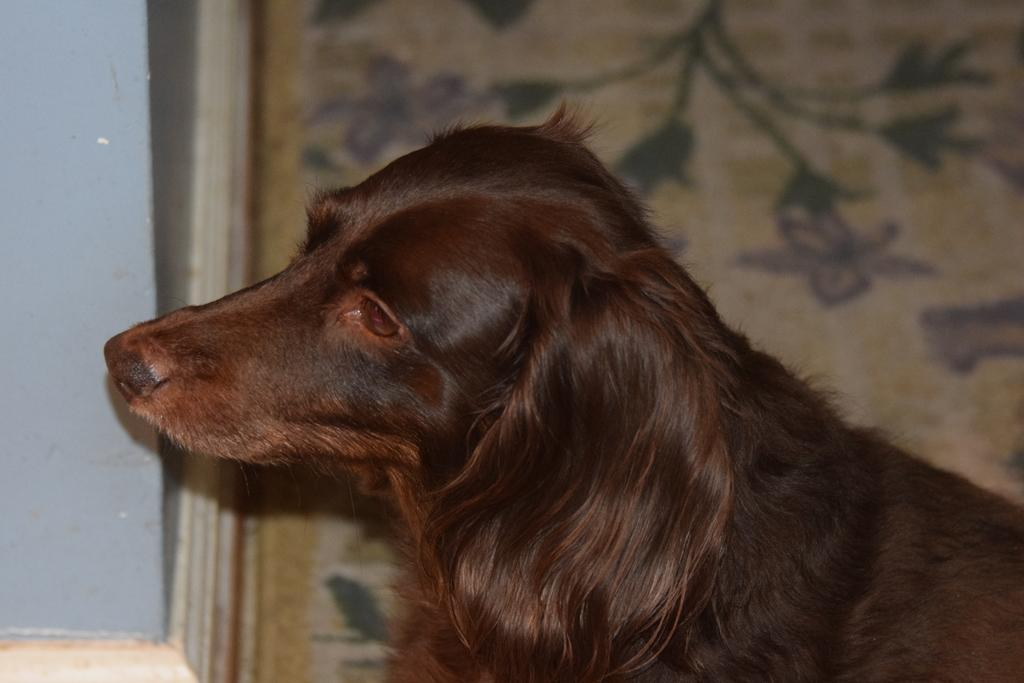What type of animal is present in the image? There is a dog in the image. What can be seen behind the dog? There is a background in the image, which contains some design. What architectural feature is visible in the background? There is a wall visible in the background. What type of dress is the representative wearing in the image? There is no representative or dress present in the image; it features a dog and a background with a wall. 